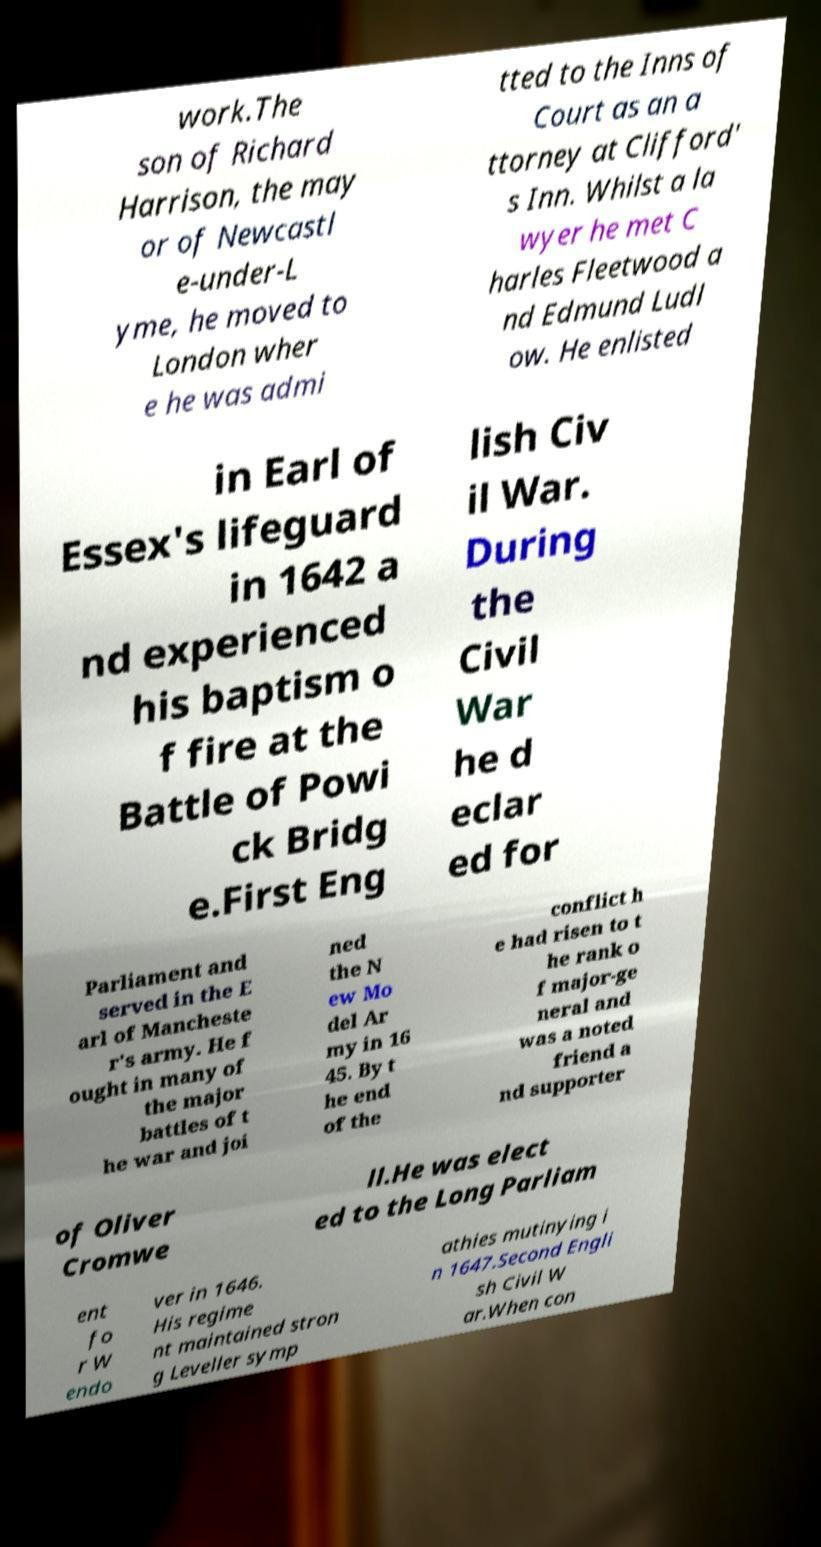What messages or text are displayed in this image? I need them in a readable, typed format. work.The son of Richard Harrison, the may or of Newcastl e-under-L yme, he moved to London wher e he was admi tted to the Inns of Court as an a ttorney at Clifford' s Inn. Whilst a la wyer he met C harles Fleetwood a nd Edmund Ludl ow. He enlisted in Earl of Essex's lifeguard in 1642 a nd experienced his baptism o f fire at the Battle of Powi ck Bridg e.First Eng lish Civ il War. During the Civil War he d eclar ed for Parliament and served in the E arl of Mancheste r's army. He f ought in many of the major battles of t he war and joi ned the N ew Mo del Ar my in 16 45. By t he end of the conflict h e had risen to t he rank o f major-ge neral and was a noted friend a nd supporter of Oliver Cromwe ll.He was elect ed to the Long Parliam ent fo r W endo ver in 1646. His regime nt maintained stron g Leveller symp athies mutinying i n 1647.Second Engli sh Civil W ar.When con 